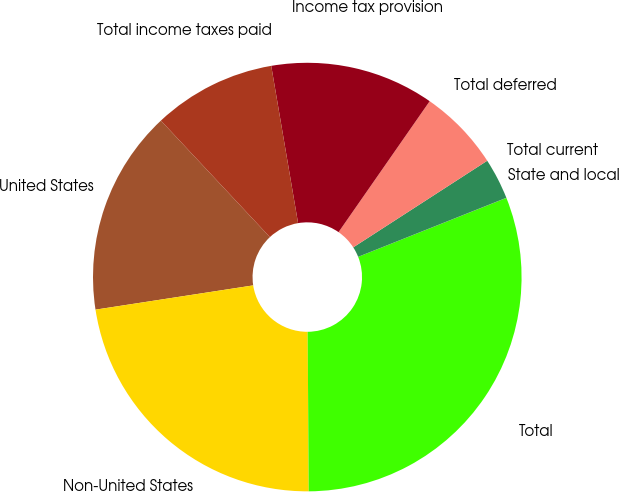Convert chart. <chart><loc_0><loc_0><loc_500><loc_500><pie_chart><fcel>United States<fcel>Non-United States<fcel>Total<fcel>State and local<fcel>Total current<fcel>Total deferred<fcel>Income tax provision<fcel>Total income taxes paid<nl><fcel>15.46%<fcel>22.68%<fcel>30.92%<fcel>0.01%<fcel>3.1%<fcel>6.19%<fcel>12.37%<fcel>9.28%<nl></chart> 